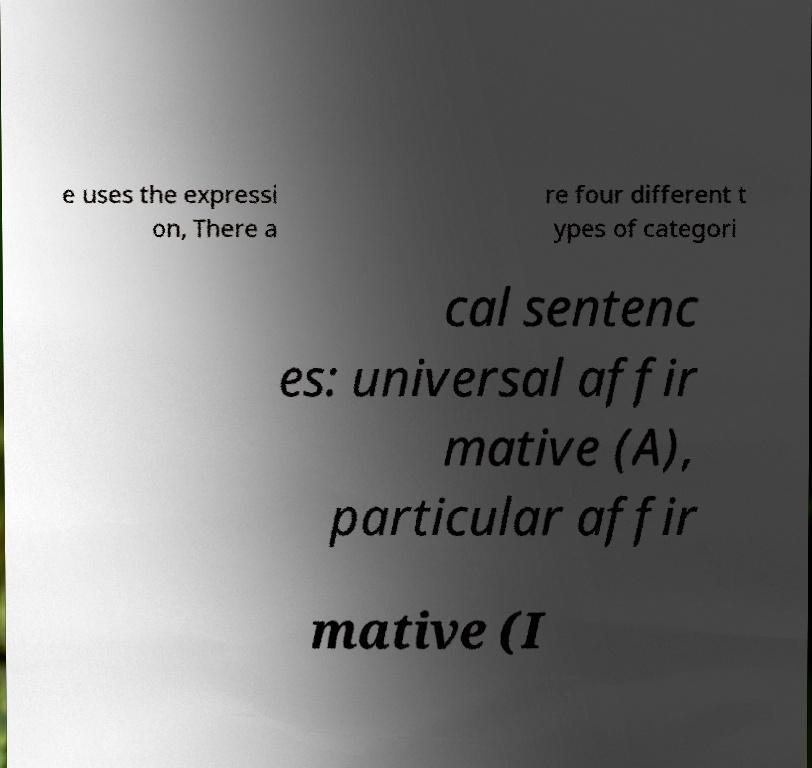What messages or text are displayed in this image? I need them in a readable, typed format. e uses the expressi on, There a re four different t ypes of categori cal sentenc es: universal affir mative (A), particular affir mative (I 